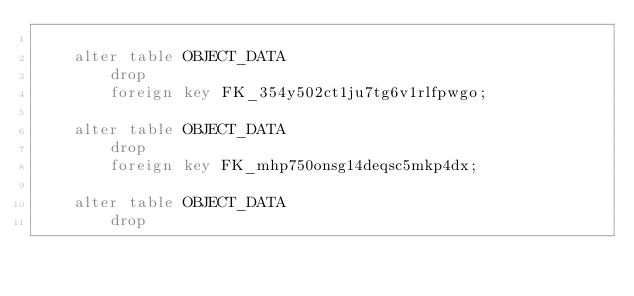<code> <loc_0><loc_0><loc_500><loc_500><_SQL_>
    alter table OBJECT_DATA 
        drop 
        foreign key FK_354y502ct1ju7tg6v1rlfpwgo;

    alter table OBJECT_DATA 
        drop 
        foreign key FK_mhp750onsg14deqsc5mkp4dx;

    alter table OBJECT_DATA 
        drop </code> 